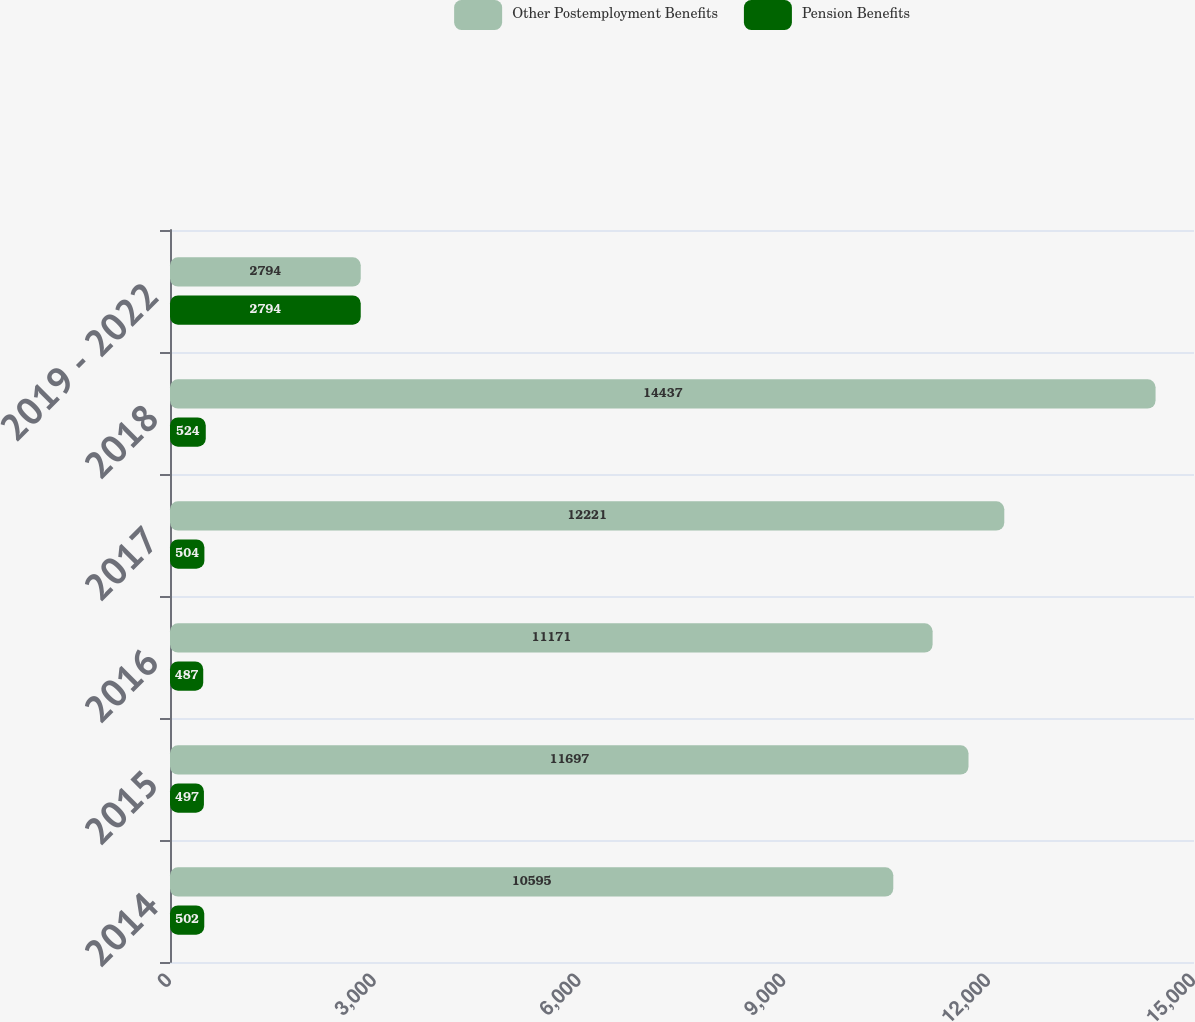Convert chart to OTSL. <chart><loc_0><loc_0><loc_500><loc_500><stacked_bar_chart><ecel><fcel>2014<fcel>2015<fcel>2016<fcel>2017<fcel>2018<fcel>2019 - 2022<nl><fcel>Other Postemployment Benefits<fcel>10595<fcel>11697<fcel>11171<fcel>12221<fcel>14437<fcel>2794<nl><fcel>Pension Benefits<fcel>502<fcel>497<fcel>487<fcel>504<fcel>524<fcel>2794<nl></chart> 